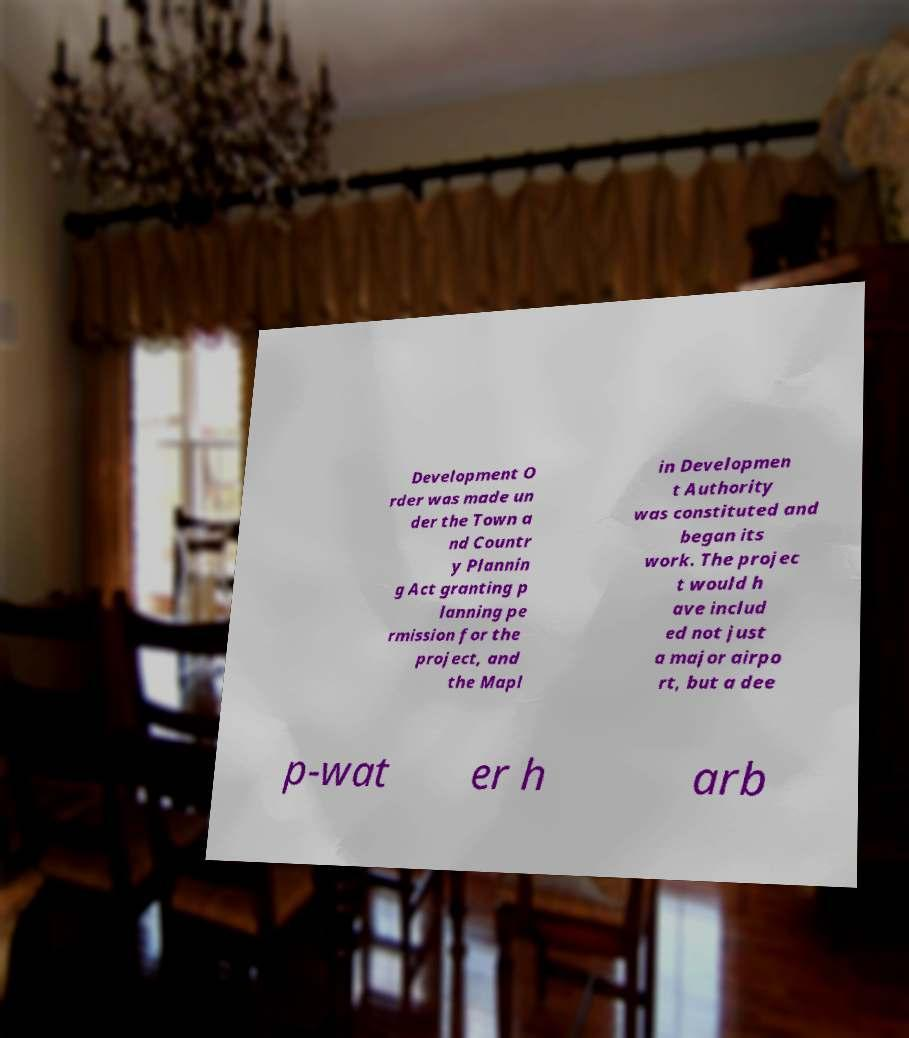What messages or text are displayed in this image? I need them in a readable, typed format. Development O rder was made un der the Town a nd Countr y Plannin g Act granting p lanning pe rmission for the project, and the Mapl in Developmen t Authority was constituted and began its work. The projec t would h ave includ ed not just a major airpo rt, but a dee p-wat er h arb 